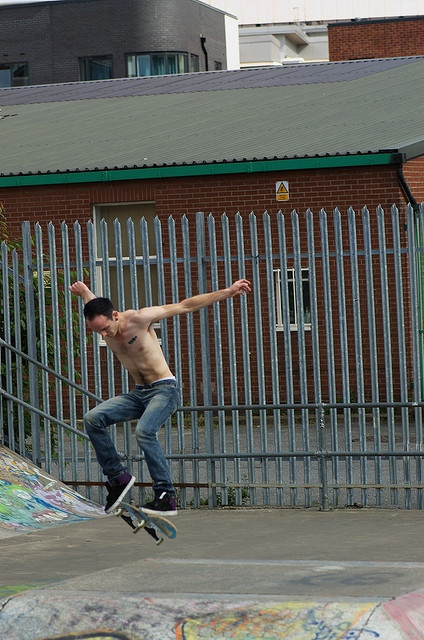Describe the objects in this image and their specific colors. I can see people in lavender, black, gray, and blue tones and skateboard in lavender, gray, black, and blue tones in this image. 